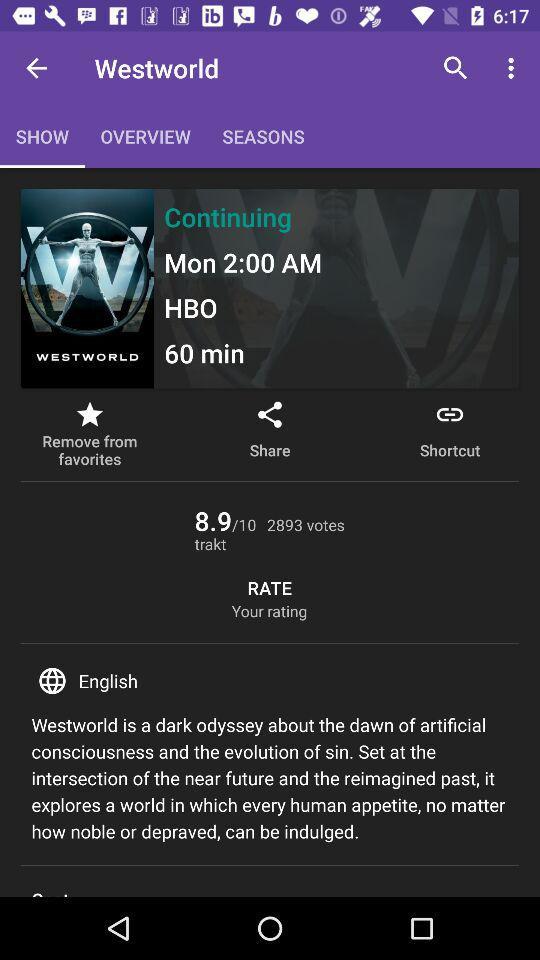What is the rating of the show? The rating is 8.9. 